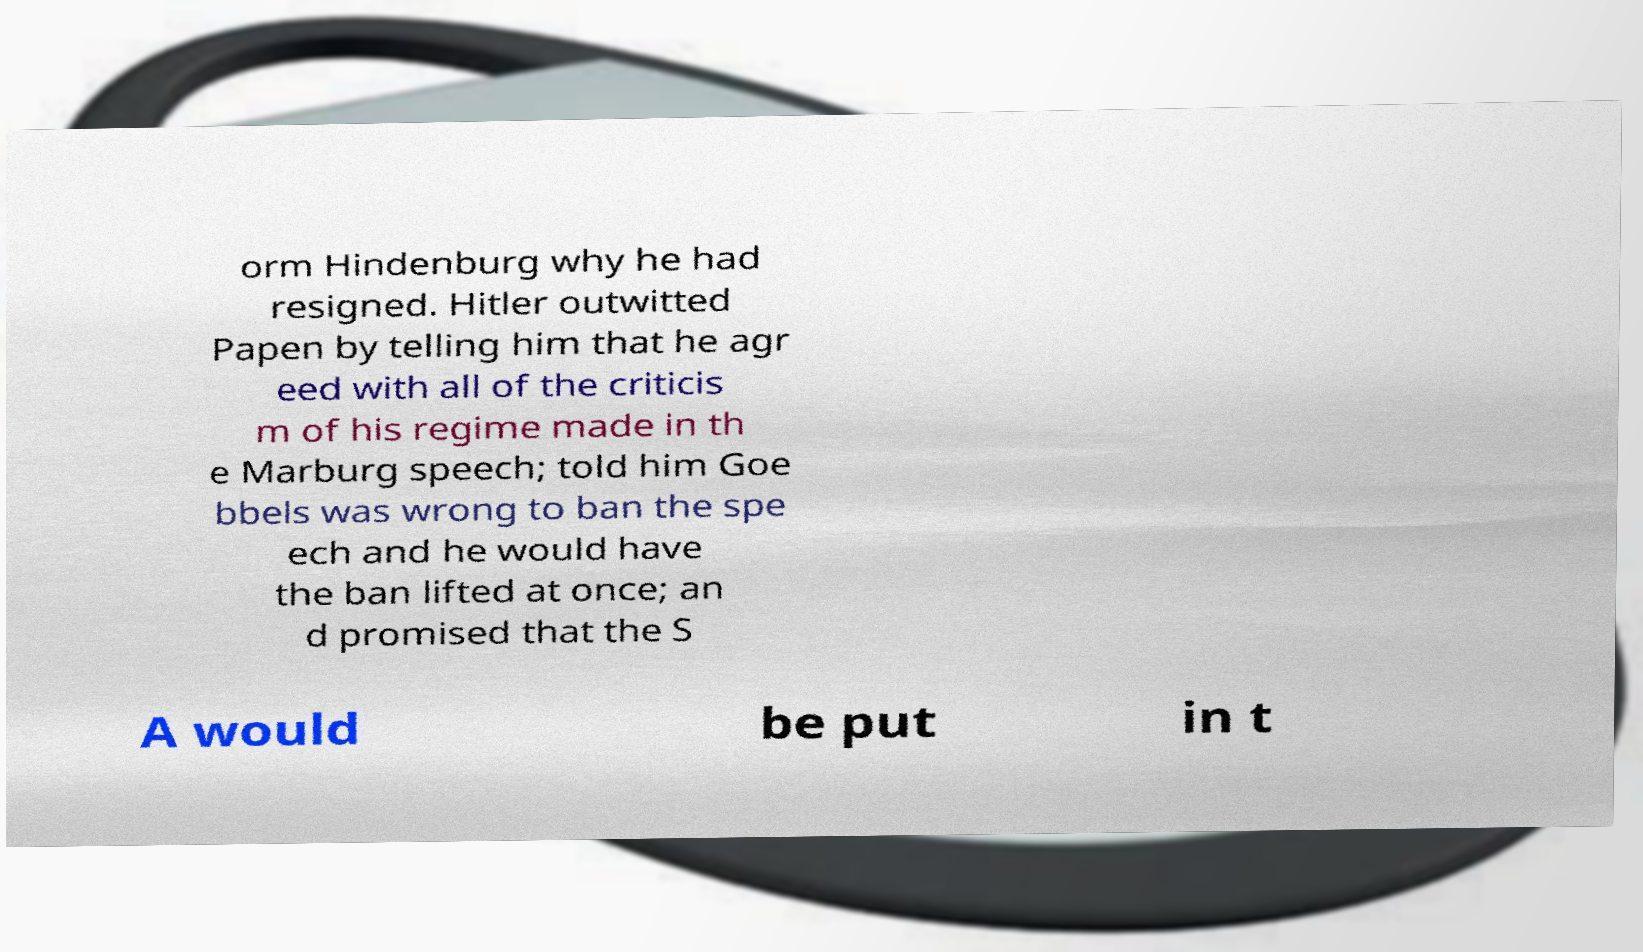For documentation purposes, I need the text within this image transcribed. Could you provide that? orm Hindenburg why he had resigned. Hitler outwitted Papen by telling him that he agr eed with all of the criticis m of his regime made in th e Marburg speech; told him Goe bbels was wrong to ban the spe ech and he would have the ban lifted at once; an d promised that the S A would be put in t 